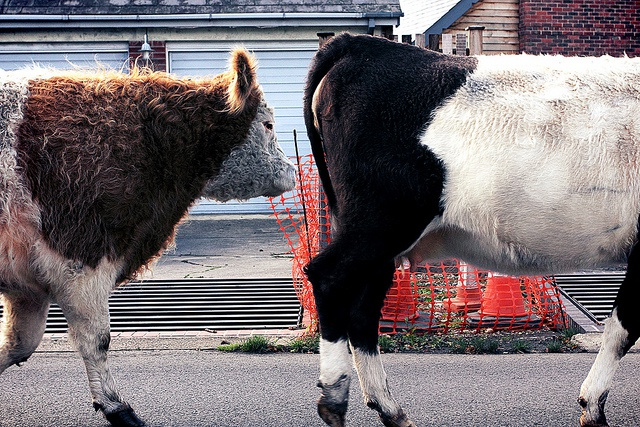Describe the objects in this image and their specific colors. I can see cow in gray, black, lightgray, and darkgray tones and cow in gray, black, and darkgray tones in this image. 